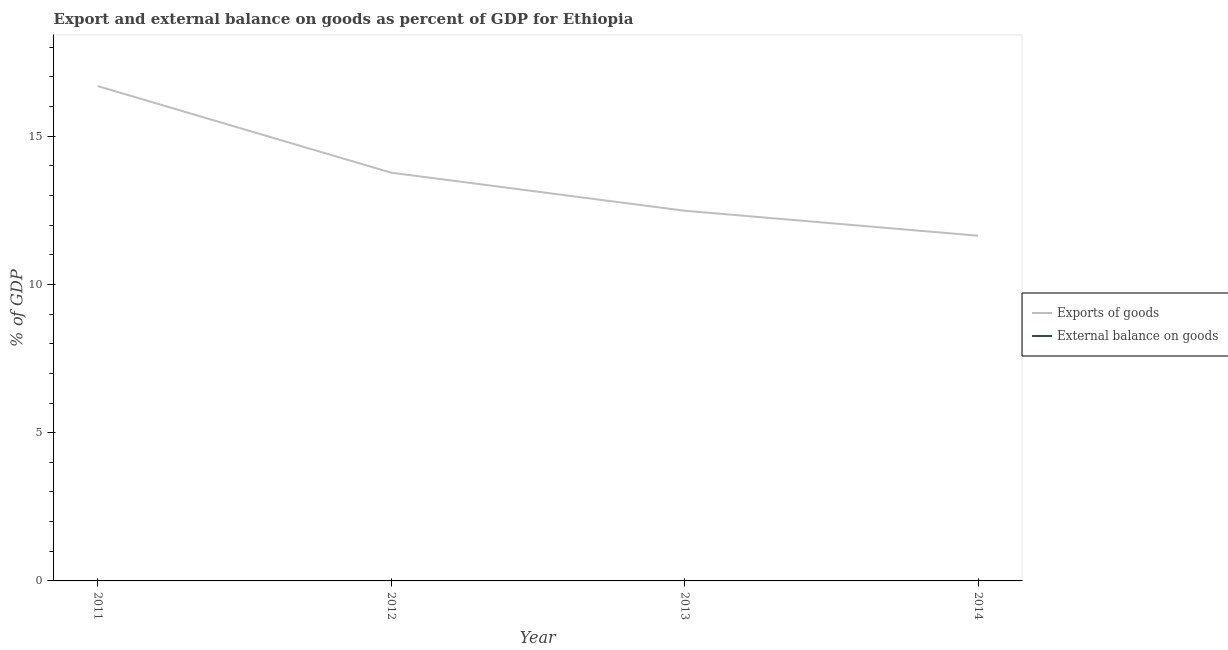Does the line corresponding to external balance on goods as percentage of gdp intersect with the line corresponding to export of goods as percentage of gdp?
Make the answer very short. No. Across all years, what is the maximum export of goods as percentage of gdp?
Give a very brief answer. 16.69. Across all years, what is the minimum external balance on goods as percentage of gdp?
Your response must be concise. 0. What is the total external balance on goods as percentage of gdp in the graph?
Make the answer very short. 0. What is the difference between the export of goods as percentage of gdp in 2011 and that in 2012?
Provide a short and direct response. 2.92. What is the difference between the external balance on goods as percentage of gdp in 2014 and the export of goods as percentage of gdp in 2011?
Ensure brevity in your answer.  -16.69. What is the average external balance on goods as percentage of gdp per year?
Ensure brevity in your answer.  0. What is the ratio of the export of goods as percentage of gdp in 2011 to that in 2014?
Your response must be concise. 1.43. What is the difference between the highest and the second highest export of goods as percentage of gdp?
Make the answer very short. 2.92. What is the difference between the highest and the lowest export of goods as percentage of gdp?
Provide a short and direct response. 5.05. In how many years, is the export of goods as percentage of gdp greater than the average export of goods as percentage of gdp taken over all years?
Your response must be concise. 2. Is the external balance on goods as percentage of gdp strictly greater than the export of goods as percentage of gdp over the years?
Make the answer very short. No. How many lines are there?
Your answer should be compact. 1. What is the difference between two consecutive major ticks on the Y-axis?
Give a very brief answer. 5. Are the values on the major ticks of Y-axis written in scientific E-notation?
Provide a succinct answer. No. Does the graph contain grids?
Your answer should be compact. No. How many legend labels are there?
Your answer should be compact. 2. What is the title of the graph?
Your answer should be compact. Export and external balance on goods as percent of GDP for Ethiopia. What is the label or title of the Y-axis?
Provide a short and direct response. % of GDP. What is the % of GDP in Exports of goods in 2011?
Offer a terse response. 16.69. What is the % of GDP of Exports of goods in 2012?
Ensure brevity in your answer.  13.77. What is the % of GDP of External balance on goods in 2012?
Offer a very short reply. 0. What is the % of GDP in Exports of goods in 2013?
Ensure brevity in your answer.  12.48. What is the % of GDP of Exports of goods in 2014?
Offer a very short reply. 11.64. Across all years, what is the maximum % of GDP in Exports of goods?
Give a very brief answer. 16.69. Across all years, what is the minimum % of GDP of Exports of goods?
Your answer should be very brief. 11.64. What is the total % of GDP of Exports of goods in the graph?
Your response must be concise. 54.58. What is the difference between the % of GDP in Exports of goods in 2011 and that in 2012?
Your answer should be compact. 2.92. What is the difference between the % of GDP of Exports of goods in 2011 and that in 2013?
Ensure brevity in your answer.  4.2. What is the difference between the % of GDP in Exports of goods in 2011 and that in 2014?
Offer a terse response. 5.05. What is the difference between the % of GDP in Exports of goods in 2012 and that in 2013?
Your answer should be very brief. 1.28. What is the difference between the % of GDP of Exports of goods in 2012 and that in 2014?
Give a very brief answer. 2.13. What is the difference between the % of GDP in Exports of goods in 2013 and that in 2014?
Ensure brevity in your answer.  0.84. What is the average % of GDP of Exports of goods per year?
Provide a succinct answer. 13.64. What is the ratio of the % of GDP of Exports of goods in 2011 to that in 2012?
Your response must be concise. 1.21. What is the ratio of the % of GDP in Exports of goods in 2011 to that in 2013?
Your answer should be very brief. 1.34. What is the ratio of the % of GDP of Exports of goods in 2011 to that in 2014?
Provide a short and direct response. 1.43. What is the ratio of the % of GDP in Exports of goods in 2012 to that in 2013?
Offer a very short reply. 1.1. What is the ratio of the % of GDP in Exports of goods in 2012 to that in 2014?
Your answer should be compact. 1.18. What is the ratio of the % of GDP in Exports of goods in 2013 to that in 2014?
Ensure brevity in your answer.  1.07. What is the difference between the highest and the second highest % of GDP of Exports of goods?
Offer a terse response. 2.92. What is the difference between the highest and the lowest % of GDP in Exports of goods?
Keep it short and to the point. 5.05. 